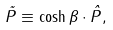<formula> <loc_0><loc_0><loc_500><loc_500>\tilde { P } \equiv \cosh \beta \cdot \hat { P } ,</formula> 